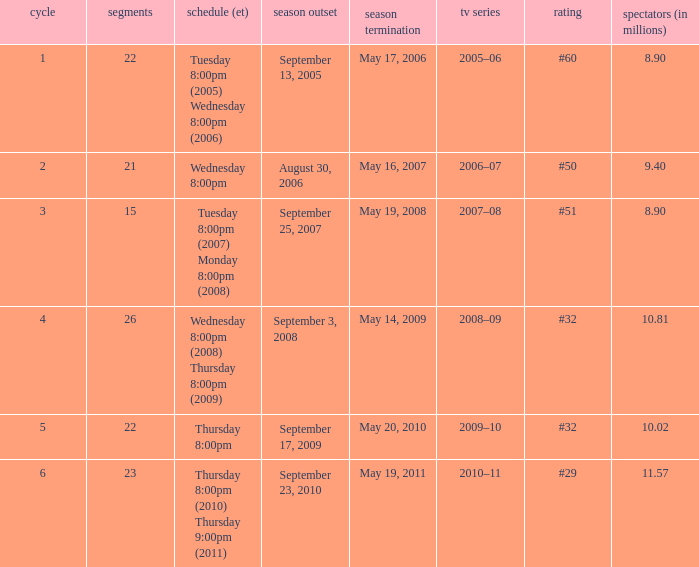In which tv season was the 23rd episode aired? 2010–11. 